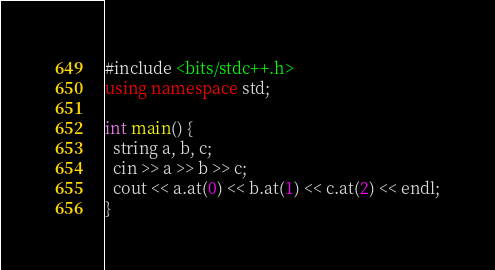<code> <loc_0><loc_0><loc_500><loc_500><_C++_>#include <bits/stdc++.h>
using namespace std;

int main() {
  string a, b, c;
  cin >> a >> b >> c;
  cout << a.at(0) << b.at(1) << c.at(2) << endl;
}
</code> 